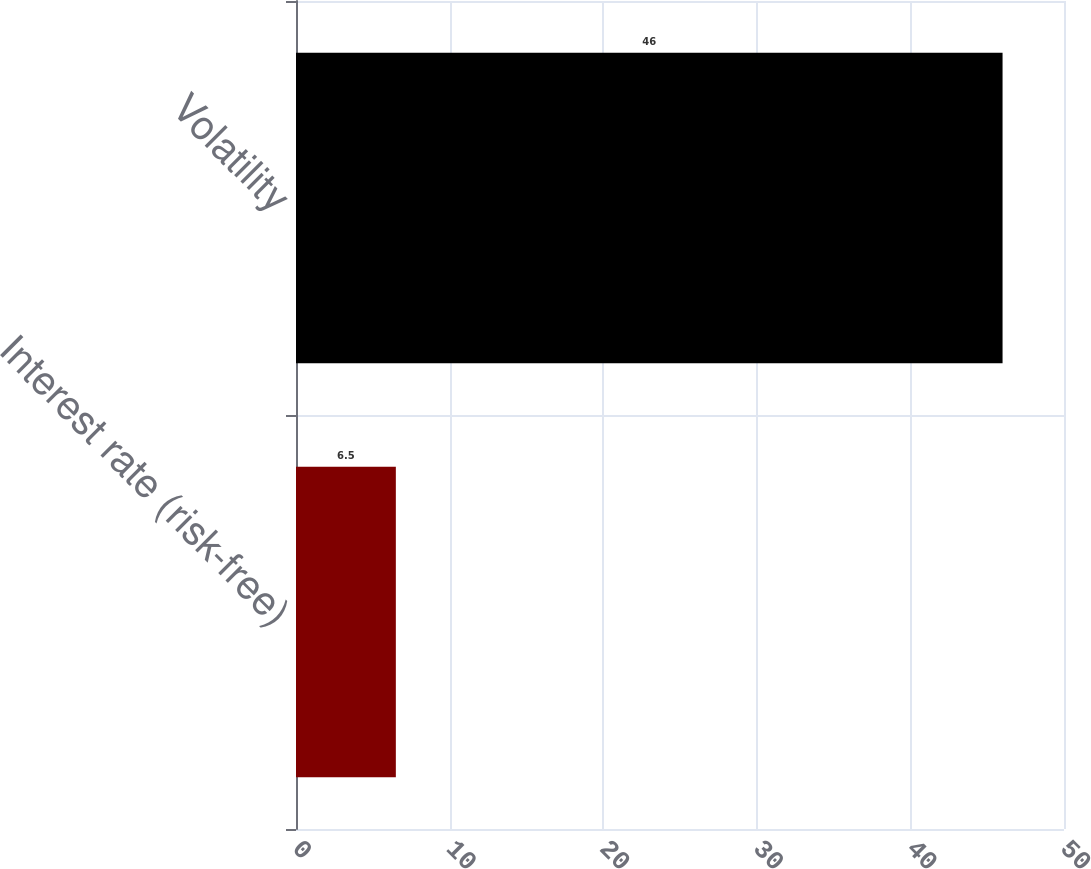Convert chart to OTSL. <chart><loc_0><loc_0><loc_500><loc_500><bar_chart><fcel>Interest rate (risk-free)<fcel>Volatility<nl><fcel>6.5<fcel>46<nl></chart> 